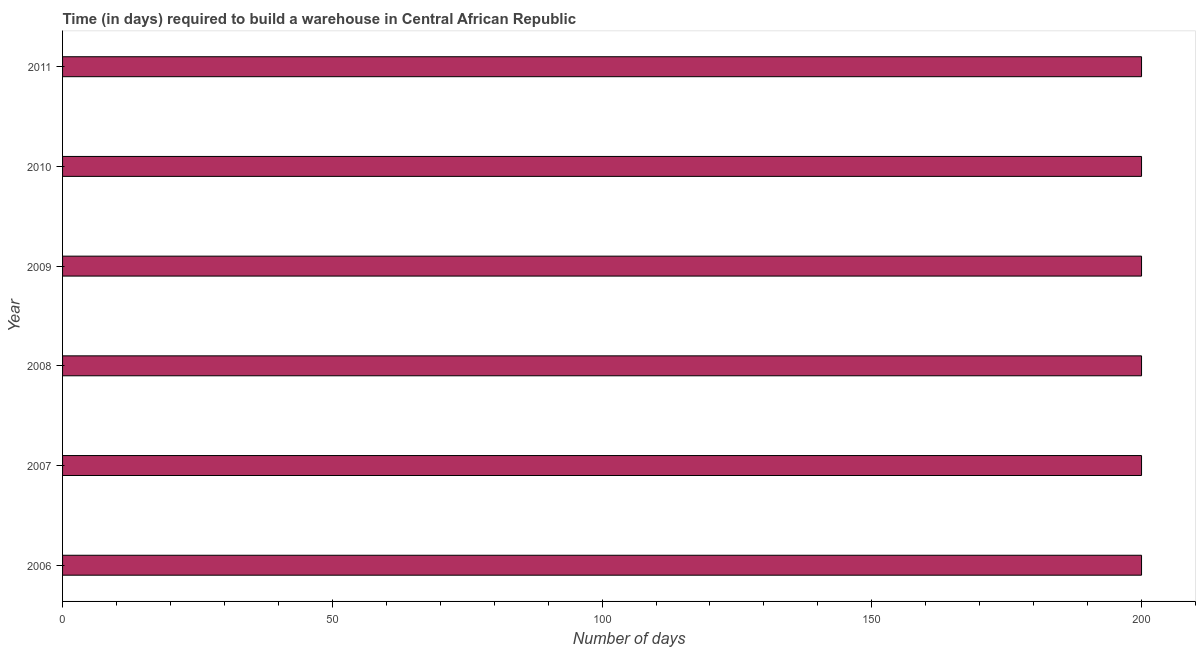Does the graph contain any zero values?
Your answer should be very brief. No. Does the graph contain grids?
Make the answer very short. No. What is the title of the graph?
Your answer should be very brief. Time (in days) required to build a warehouse in Central African Republic. What is the label or title of the X-axis?
Your answer should be compact. Number of days. In which year was the time required to build a warehouse minimum?
Give a very brief answer. 2006. What is the sum of the time required to build a warehouse?
Make the answer very short. 1200. What is the average time required to build a warehouse per year?
Give a very brief answer. 200. What is the median time required to build a warehouse?
Your response must be concise. 200. Do a majority of the years between 2006 and 2011 (inclusive) have time required to build a warehouse greater than 190 days?
Your response must be concise. Yes. What is the ratio of the time required to build a warehouse in 2007 to that in 2010?
Provide a succinct answer. 1. Is the difference between the time required to build a warehouse in 2006 and 2008 greater than the difference between any two years?
Provide a succinct answer. Yes. In how many years, is the time required to build a warehouse greater than the average time required to build a warehouse taken over all years?
Provide a succinct answer. 0. Are all the bars in the graph horizontal?
Provide a succinct answer. Yes. What is the Number of days of 2008?
Ensure brevity in your answer.  200. What is the Number of days of 2009?
Your answer should be very brief. 200. What is the Number of days in 2010?
Make the answer very short. 200. What is the Number of days in 2011?
Your answer should be very brief. 200. What is the difference between the Number of days in 2006 and 2007?
Offer a very short reply. 0. What is the difference between the Number of days in 2006 and 2011?
Offer a very short reply. 0. What is the difference between the Number of days in 2007 and 2010?
Give a very brief answer. 0. What is the difference between the Number of days in 2009 and 2010?
Keep it short and to the point. 0. What is the difference between the Number of days in 2010 and 2011?
Offer a terse response. 0. What is the ratio of the Number of days in 2006 to that in 2007?
Your answer should be compact. 1. What is the ratio of the Number of days in 2006 to that in 2008?
Ensure brevity in your answer.  1. What is the ratio of the Number of days in 2006 to that in 2011?
Your answer should be very brief. 1. What is the ratio of the Number of days in 2007 to that in 2009?
Provide a succinct answer. 1. What is the ratio of the Number of days in 2007 to that in 2011?
Keep it short and to the point. 1. What is the ratio of the Number of days in 2008 to that in 2010?
Provide a succinct answer. 1. What is the ratio of the Number of days in 2008 to that in 2011?
Give a very brief answer. 1. What is the ratio of the Number of days in 2010 to that in 2011?
Keep it short and to the point. 1. 